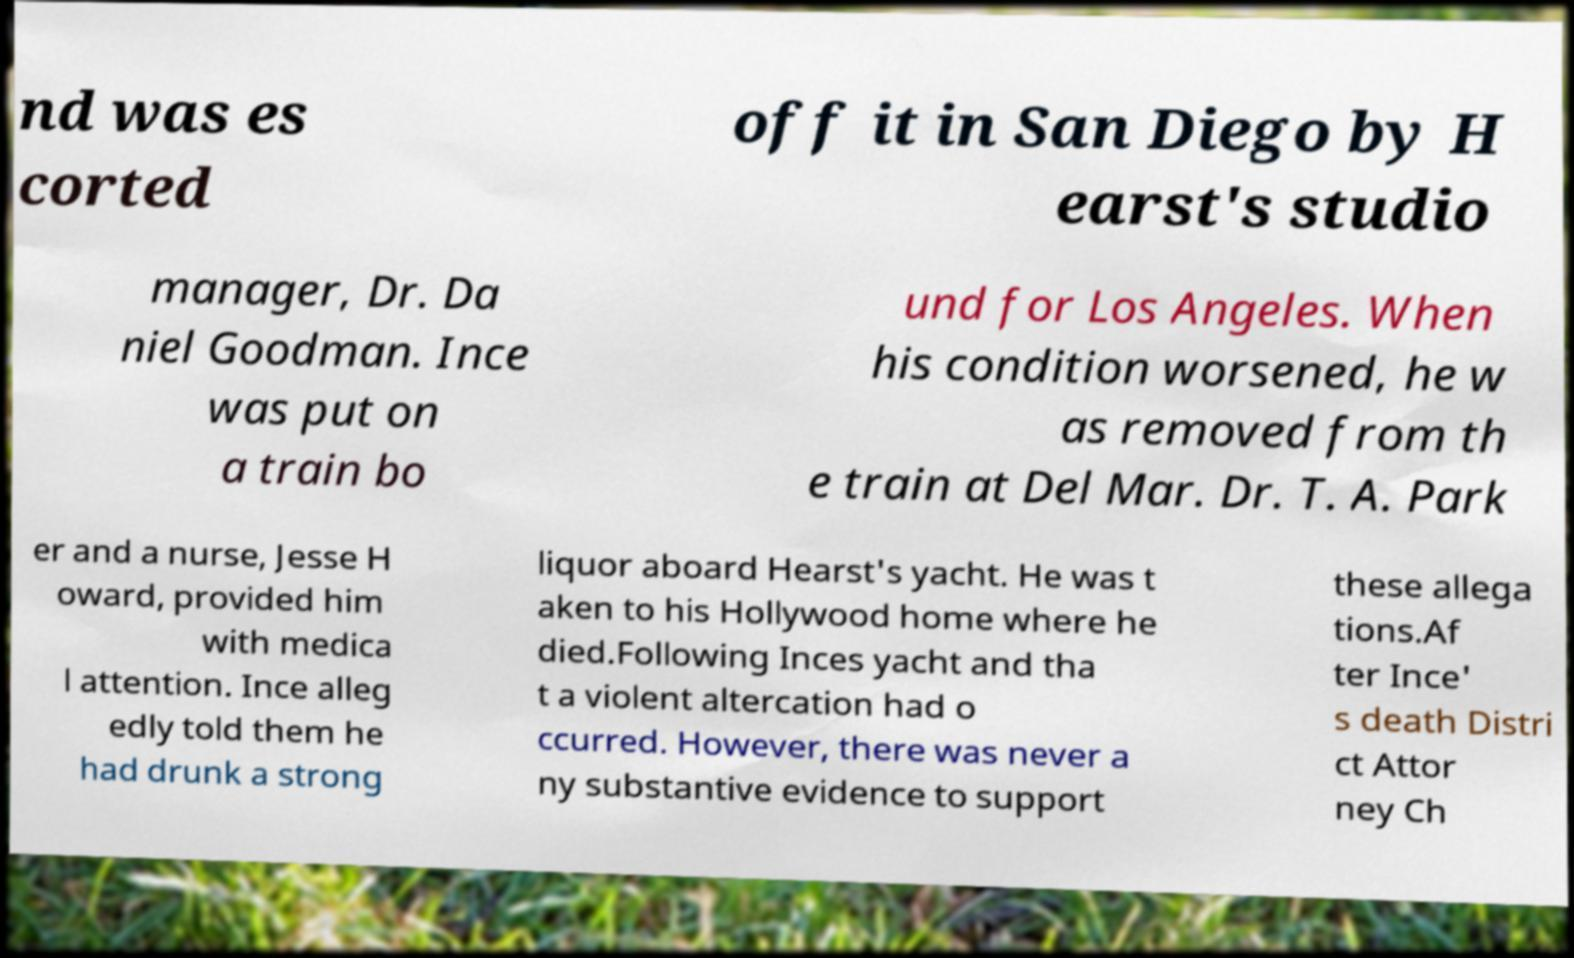There's text embedded in this image that I need extracted. Can you transcribe it verbatim? nd was es corted off it in San Diego by H earst's studio manager, Dr. Da niel Goodman. Ince was put on a train bo und for Los Angeles. When his condition worsened, he w as removed from th e train at Del Mar. Dr. T. A. Park er and a nurse, Jesse H oward, provided him with medica l attention. Ince alleg edly told them he had drunk a strong liquor aboard Hearst's yacht. He was t aken to his Hollywood home where he died.Following Inces yacht and tha t a violent altercation had o ccurred. However, there was never a ny substantive evidence to support these allega tions.Af ter Ince' s death Distri ct Attor ney Ch 